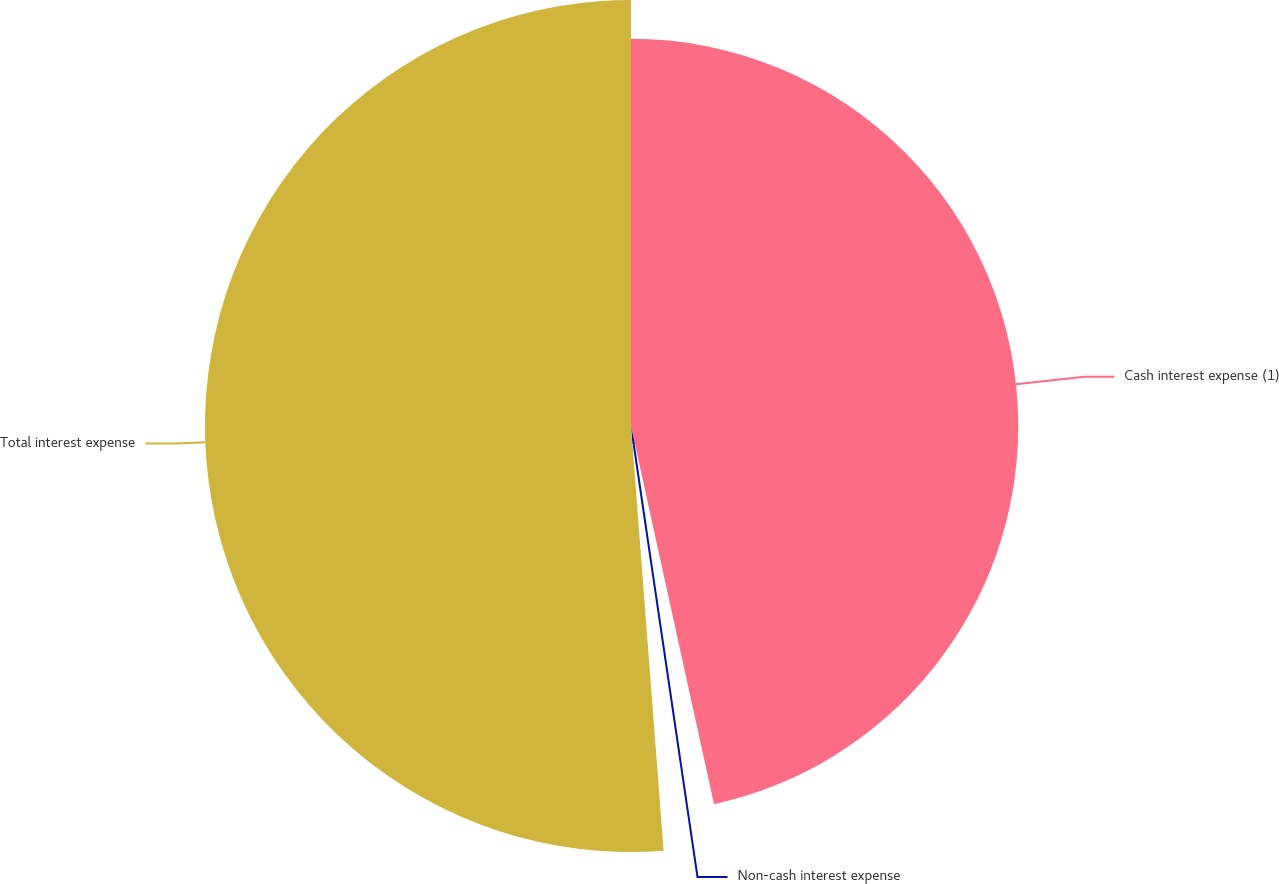Convert chart. <chart><loc_0><loc_0><loc_500><loc_500><pie_chart><fcel>Cash interest expense (1)<fcel>Non-cash interest expense<fcel>Total interest expense<nl><fcel>46.56%<fcel>2.22%<fcel>51.22%<nl></chart> 